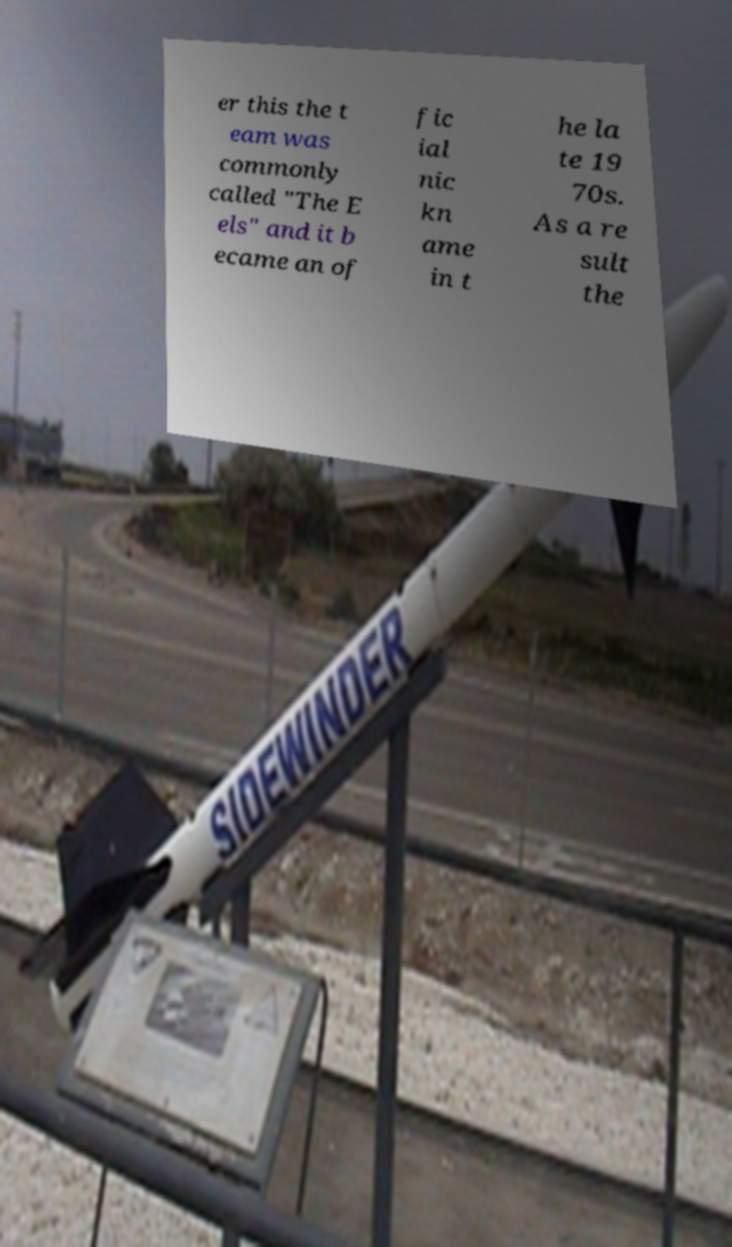What messages or text are displayed in this image? I need them in a readable, typed format. er this the t eam was commonly called "The E els" and it b ecame an of fic ial nic kn ame in t he la te 19 70s. As a re sult the 